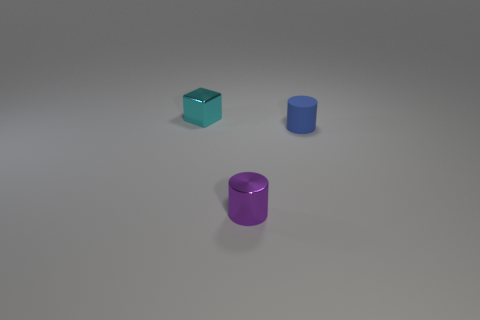Add 3 big green cylinders. How many objects exist? 6 Subtract all blocks. How many objects are left? 2 Add 1 matte things. How many matte things exist? 2 Subtract 0 green cylinders. How many objects are left? 3 Subtract all small gray cylinders. Subtract all small shiny cubes. How many objects are left? 2 Add 1 small blue matte cylinders. How many small blue matte cylinders are left? 2 